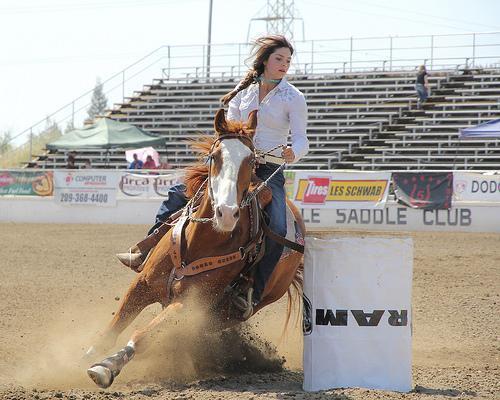How many people are walking up stairs in this image?
Give a very brief answer. 1. 